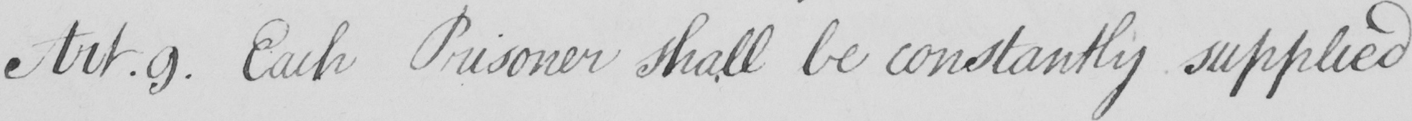What is written in this line of handwriting? Each Prisoner shall be constantly supplied 